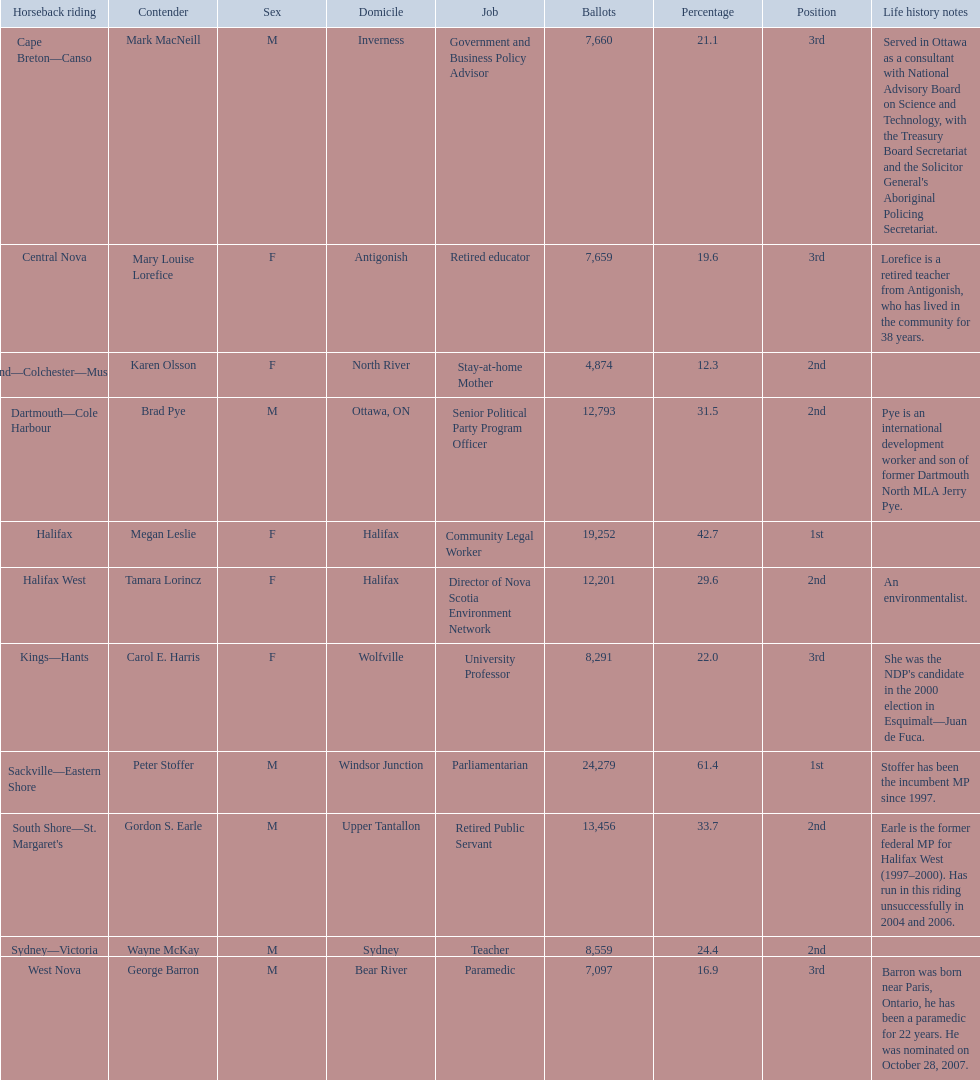Who are all the candidates? Mark MacNeill, Mary Louise Lorefice, Karen Olsson, Brad Pye, Megan Leslie, Tamara Lorincz, Carol E. Harris, Peter Stoffer, Gordon S. Earle, Wayne McKay, George Barron. How many votes did they receive? 7,660, 7,659, 4,874, 12,793, 19,252, 12,201, 8,291, 24,279, 13,456, 8,559, 7,097. And of those, how many were for megan leslie? 19,252. 